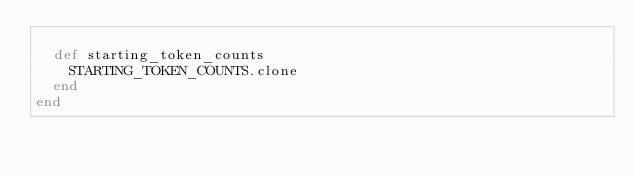Convert code to text. <code><loc_0><loc_0><loc_500><loc_500><_Ruby_>
  def starting_token_counts
    STARTING_TOKEN_COUNTS.clone
  end
end

</code> 